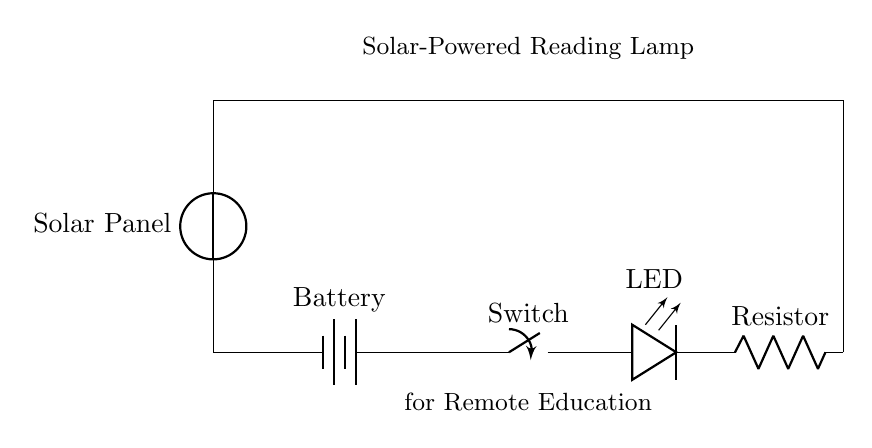What is the main function of this circuit? The main function of this circuit is to power an LED light for reading, by utilizing energy harvested from a solar panel.
Answer: Power LED light What type of energy source is used in this circuit? The circuit uses a solar panel as the energy source, converting sunlight into electrical energy.
Answer: Solar panel Which component stores energy in this circuit? The component that stores energy in this circuit is the battery, which accumulates the energy received from the solar panel.
Answer: Battery What happens if the switch is turned off? If the switch is turned off, the circuit becomes open, preventing current from flowing and turning off the LED light.
Answer: LED turns off How many components are in series in this circuit? There are four components in series: the battery, the switch, the LED, and the resistor.
Answer: Four components What is the purpose of the resistor in this circuit? The resistor limits the current flowing to the LED, protecting it from receiving too much current and potentially getting damaged.
Answer: Current limiting If the solar panel produces a voltage of 5 volts, what is the total voltage in this circuit? Since this is a series circuit and only one voltage source is present, the total voltage remains 5 volts provided by the solar panel itself.
Answer: Five volts 